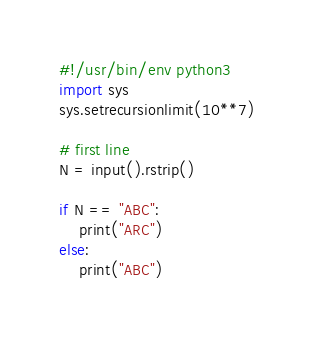<code> <loc_0><loc_0><loc_500><loc_500><_Python_>#!/usr/bin/env python3
import sys
sys.setrecursionlimit(10**7)

# first line
N = input().rstrip()

if N == "ABC":
    print("ARC")
else:
    print("ABC")
</code> 